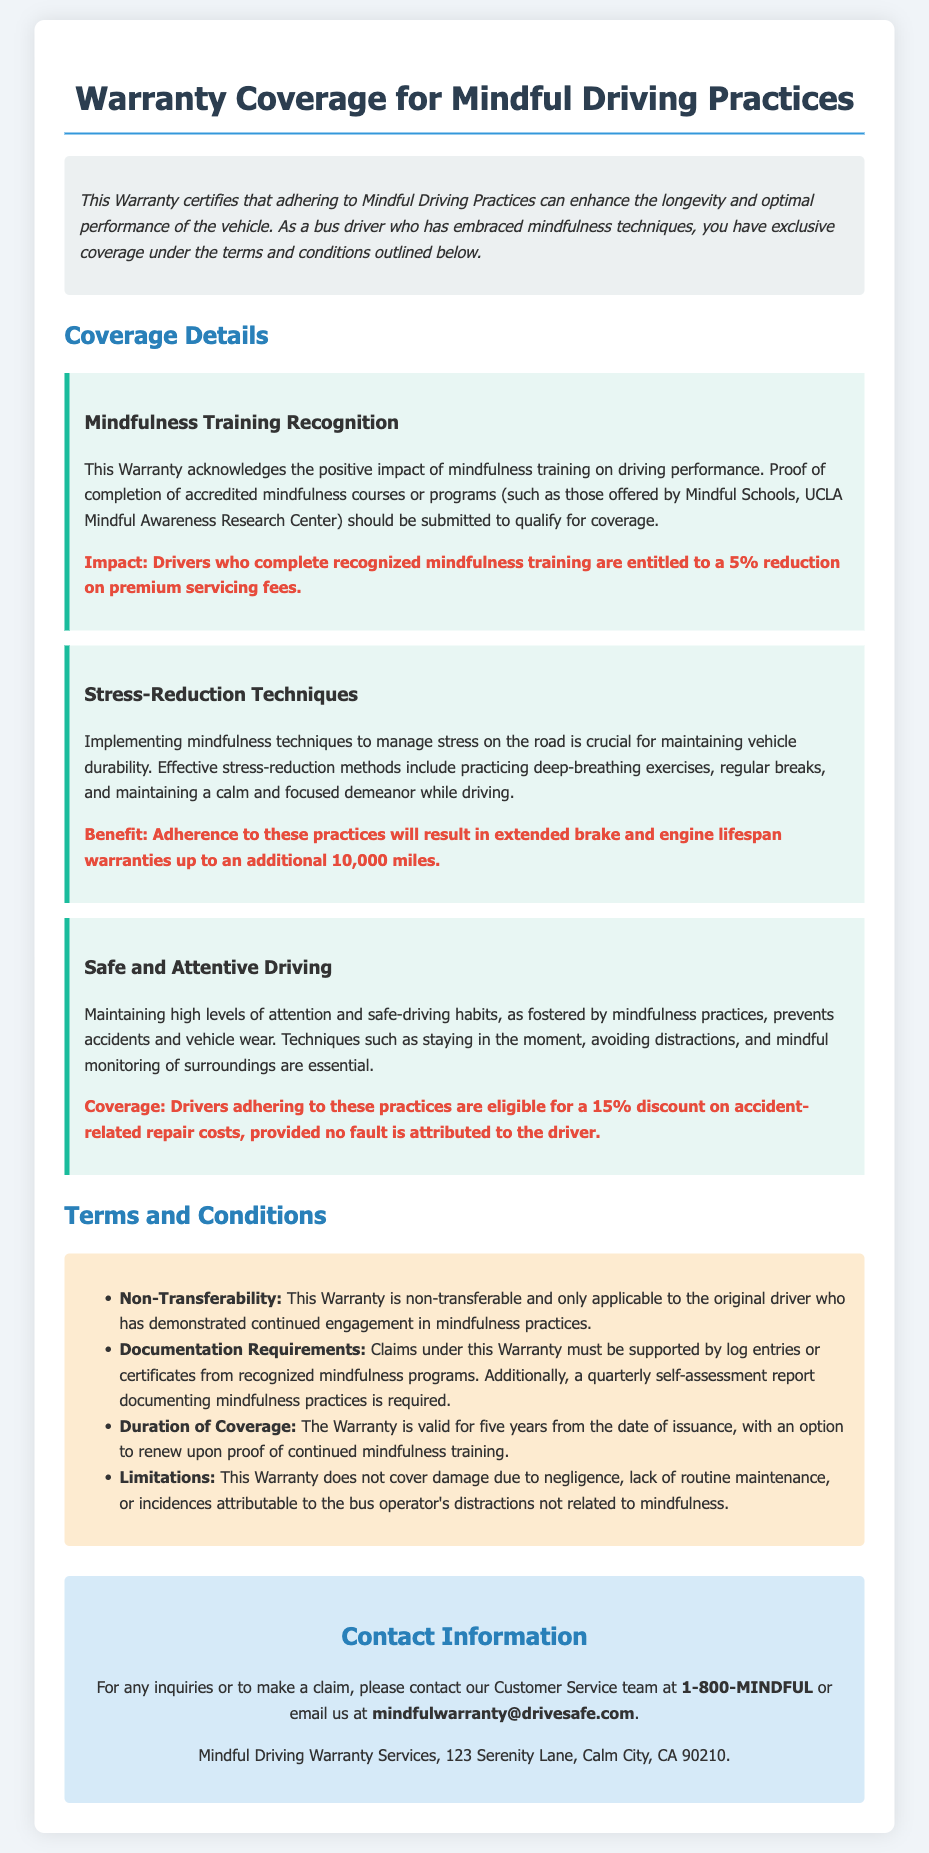What is the impact of completing recognized mindfulness training? The impact is a 5% reduction on premium servicing fees for drivers who complete recognized mindfulness training.
Answer: 5% reduction What additional mileage do stress-reduction techniques provide for warranty coverage? Adherence to stress-reduction techniques will result in extended brake and engine lifespan warranties up to an additional 10,000 miles.
Answer: 10,000 miles What is the duration of the warranty coverage? The warranty is valid for five years from the date of issuance.
Answer: five years What is required for claims under this warranty? Claims must be supported by log entries or certificates from recognized mindfulness programs and a quarterly self-assessment report documenting mindfulness practices.
Answer: log entries or certificates Is the warranty transferability allowed? The warranty is non-transferable and only applicable to the original driver who has demonstrated continued engagement in mindfulness practices.
Answer: non-transferable What discount is offered for accident-related repair costs? Drivers adhering to safe and attentive driving practices are eligible for a 15% discount on accident-related repair costs, provided no fault is attributed to the driver.
Answer: 15% discount What techniques are included under stress-reduction methods? Effective stress-reduction methods include practicing deep-breathing exercises, regular breaks, and maintaining a calm and focused demeanor while driving.
Answer: deep-breathing exercises What is the contact number for customer service? The contact number for customer service is 1-800-MINDFUL.
Answer: 1-800-MINDFUL 